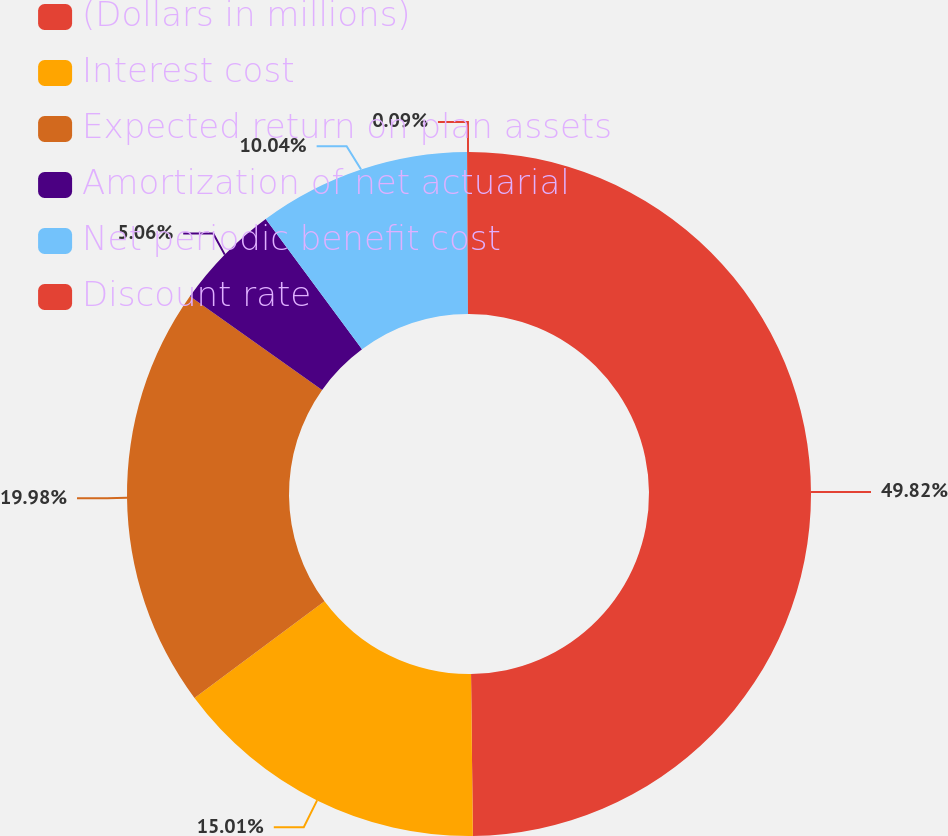Convert chart. <chart><loc_0><loc_0><loc_500><loc_500><pie_chart><fcel>(Dollars in millions)<fcel>Interest cost<fcel>Expected return on plan assets<fcel>Amortization of net actuarial<fcel>Net periodic benefit cost<fcel>Discount rate<nl><fcel>49.82%<fcel>15.01%<fcel>19.98%<fcel>5.06%<fcel>10.04%<fcel>0.09%<nl></chart> 